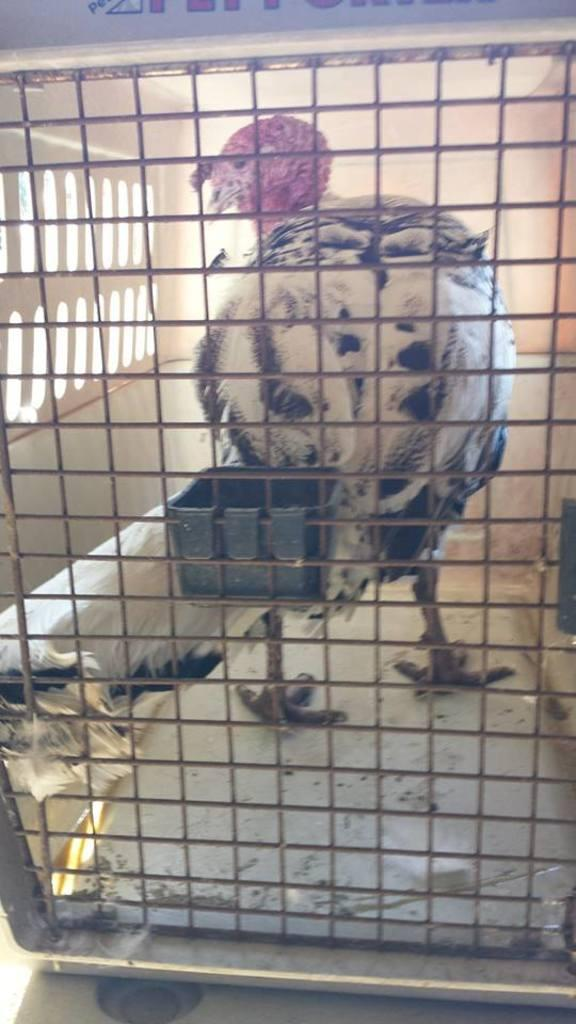What animal is present in the image? There is a hen in the image. Where is the hen located? The hen is standing in a cage. What additional object is attached to the cage? There is a small plastic square bowl attached to the cage. What type of leather material can be seen on the hen in the image? There is no leather material present on the hen in the image; it is a live animal. 